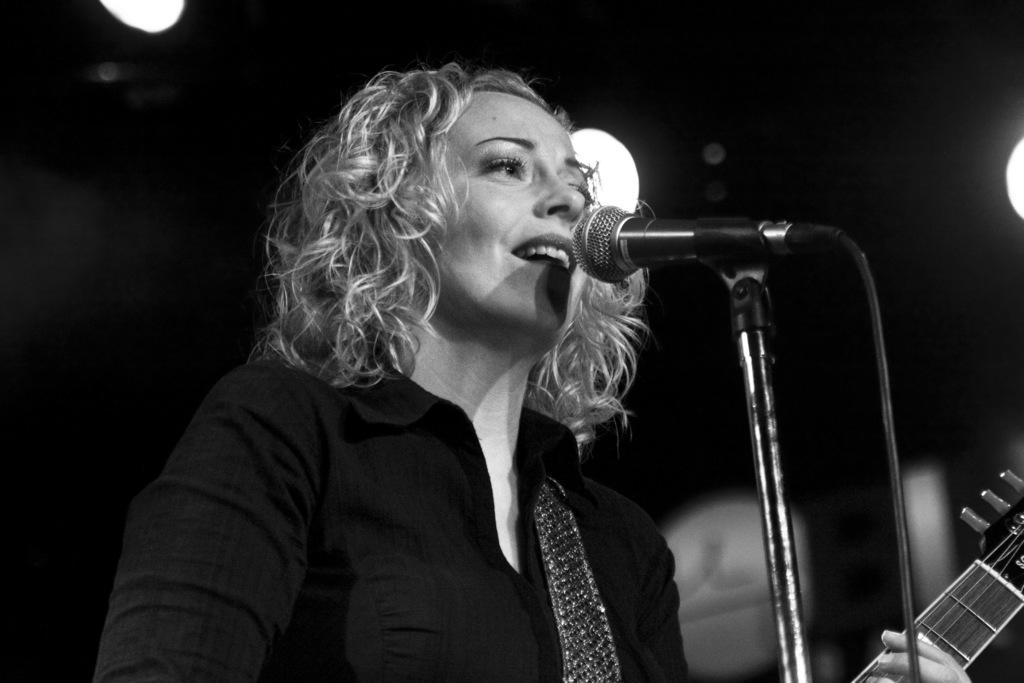Who is the main subject in the image? There is a woman in the image. What is the woman holding in the image? The woman is holding a microphone. What is the woman doing in the image? The woman is playing a guitar. What type of stitch is the woman using to play the guitar in the image? There is no stitch involved in playing the guitar in the image; the woman is using her hands to strum the strings. 